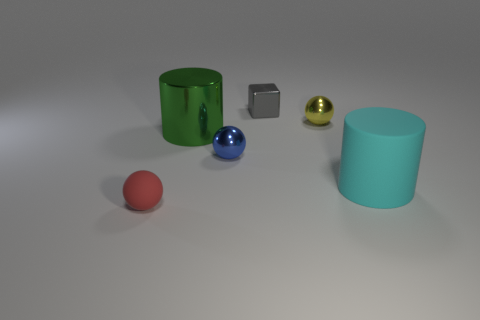Add 4 tiny purple rubber spheres. How many objects exist? 10 Subtract all cubes. How many objects are left? 5 Add 1 tiny red matte balls. How many tiny red matte balls exist? 2 Subtract 1 green cylinders. How many objects are left? 5 Subtract all cyan blocks. Subtract all shiny balls. How many objects are left? 4 Add 2 tiny matte balls. How many tiny matte balls are left? 3 